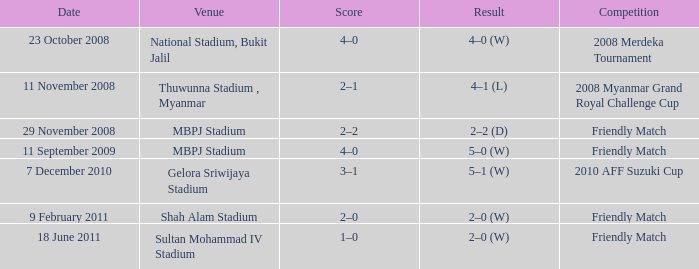What was the final score in the game at gelora sriwijaya stadium? 3–1. 